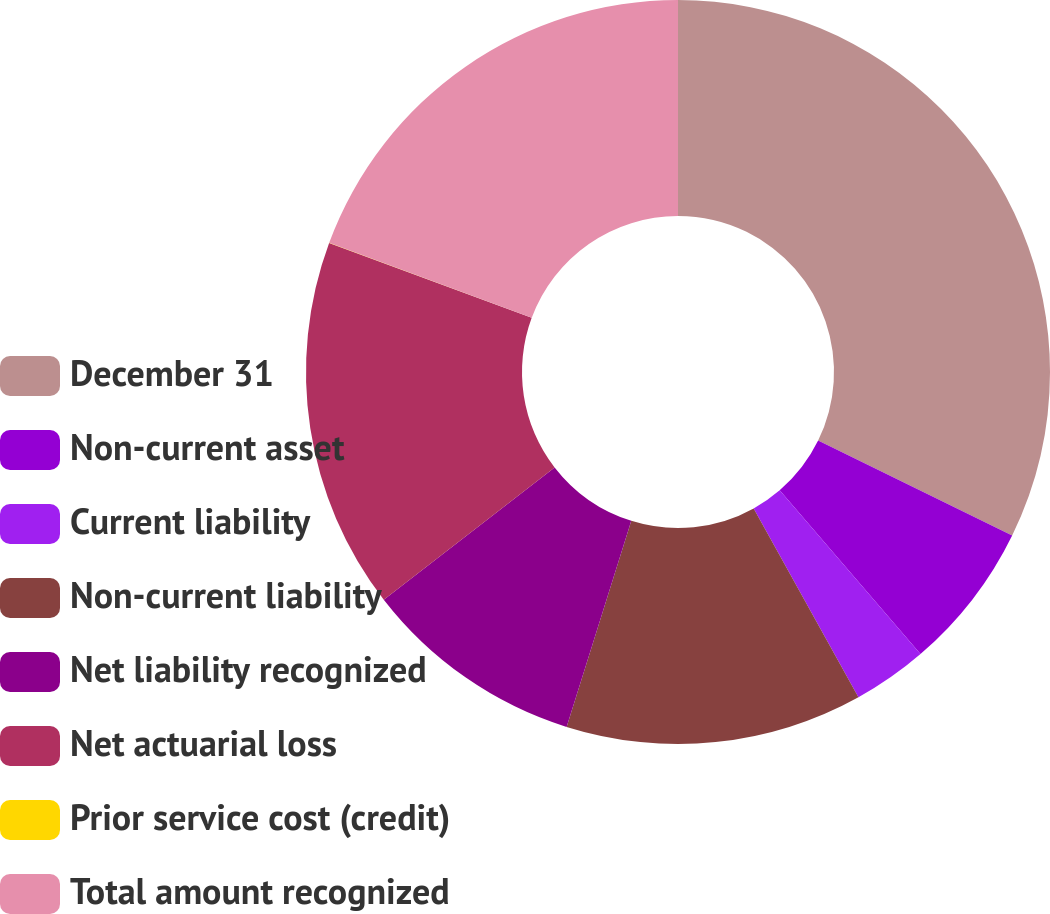<chart> <loc_0><loc_0><loc_500><loc_500><pie_chart><fcel>December 31<fcel>Non-current asset<fcel>Current liability<fcel>Non-current liability<fcel>Net liability recognized<fcel>Net actuarial loss<fcel>Prior service cost (credit)<fcel>Total amount recognized<nl><fcel>32.24%<fcel>6.46%<fcel>3.24%<fcel>12.9%<fcel>9.68%<fcel>16.12%<fcel>0.01%<fcel>19.35%<nl></chart> 